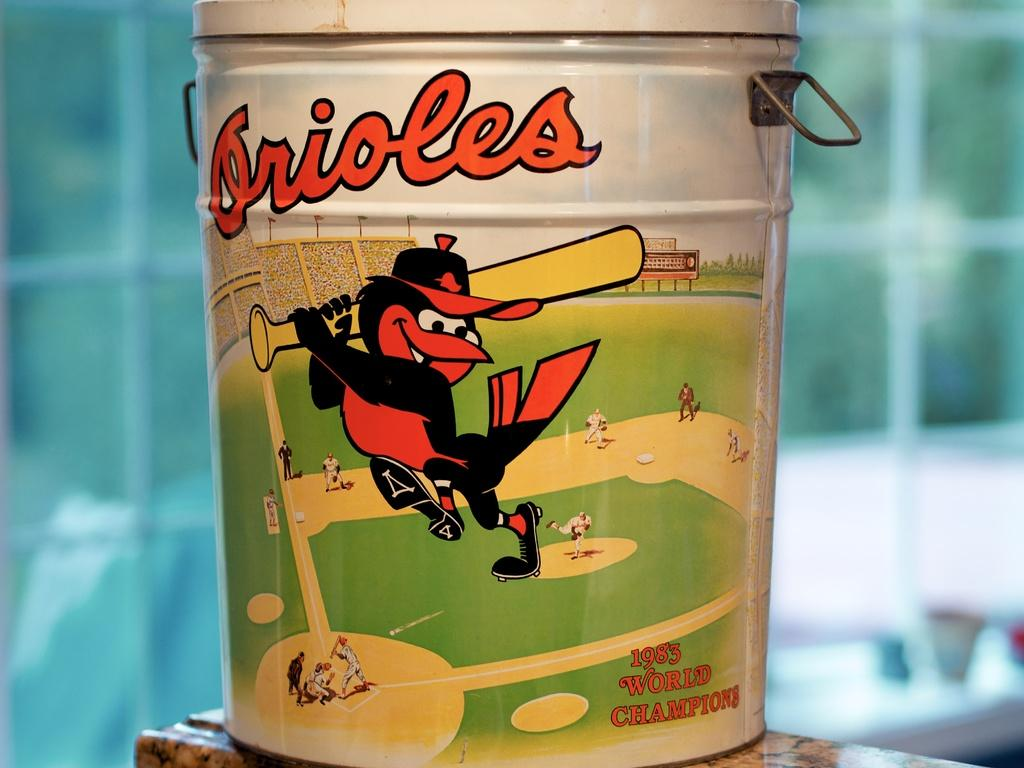Provide a one-sentence caption for the provided image. An aluminum bucket from the 1983 World Champions, featuring the Orioles, sits on a ceramic countertop. 